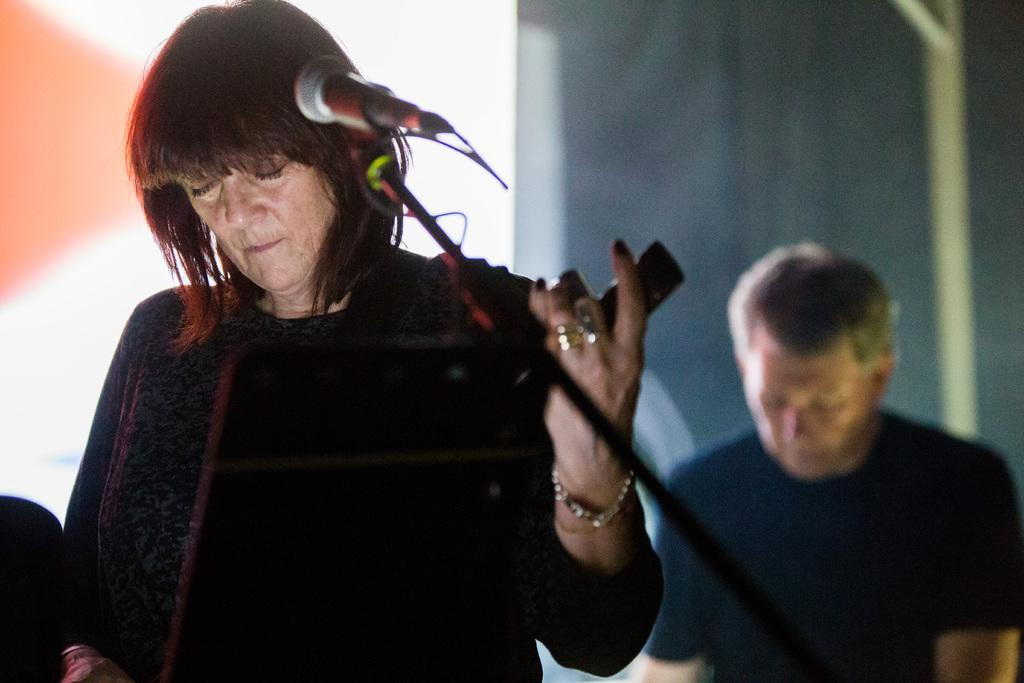Who or what is present in the image? There are people in the image. What object can be seen in the image that is typically used for amplifying sound? There is a microphone (mic) in the image. What can be seen behind the people in the image? There are objects visible in the background of the image. How would you describe the appearance of the background in the image? The background appears blurry. What type of boundary can be seen in the image? There is no boundary present in the image. How can the people in the image be helped with their performance? The image does not provide any information about the people's performance or how they might be helped. 